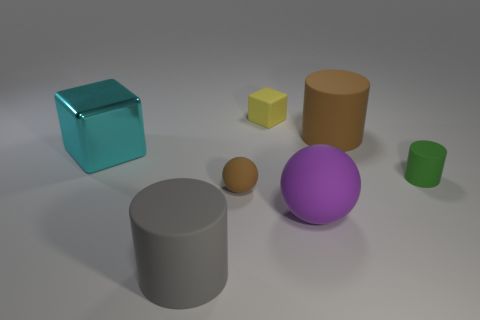There is a matte thing behind the big object that is behind the cyan cube that is in front of the brown rubber cylinder; what size is it?
Your answer should be compact. Small. There is a brown matte object in front of the tiny matte cylinder; how big is it?
Offer a terse response. Small. There is a small green object that is the same material as the yellow object; what shape is it?
Your response must be concise. Cylinder. Does the brown thing behind the small rubber cylinder have the same material as the small brown ball?
Ensure brevity in your answer.  Yes. How many other things are made of the same material as the small sphere?
Offer a very short reply. 5. How many things are either cubes that are to the left of the small yellow cube or rubber things that are left of the brown rubber cylinder?
Make the answer very short. 5. There is a brown thing behind the cyan shiny object; does it have the same shape as the big thing that is in front of the big purple matte thing?
Provide a short and direct response. Yes. What is the shape of the yellow object that is the same size as the green matte cylinder?
Your response must be concise. Cube. What number of rubber things are either large objects or cylinders?
Make the answer very short. 4. Do the big cylinder in front of the cyan object and the brown thing behind the large cyan metallic block have the same material?
Make the answer very short. Yes. 